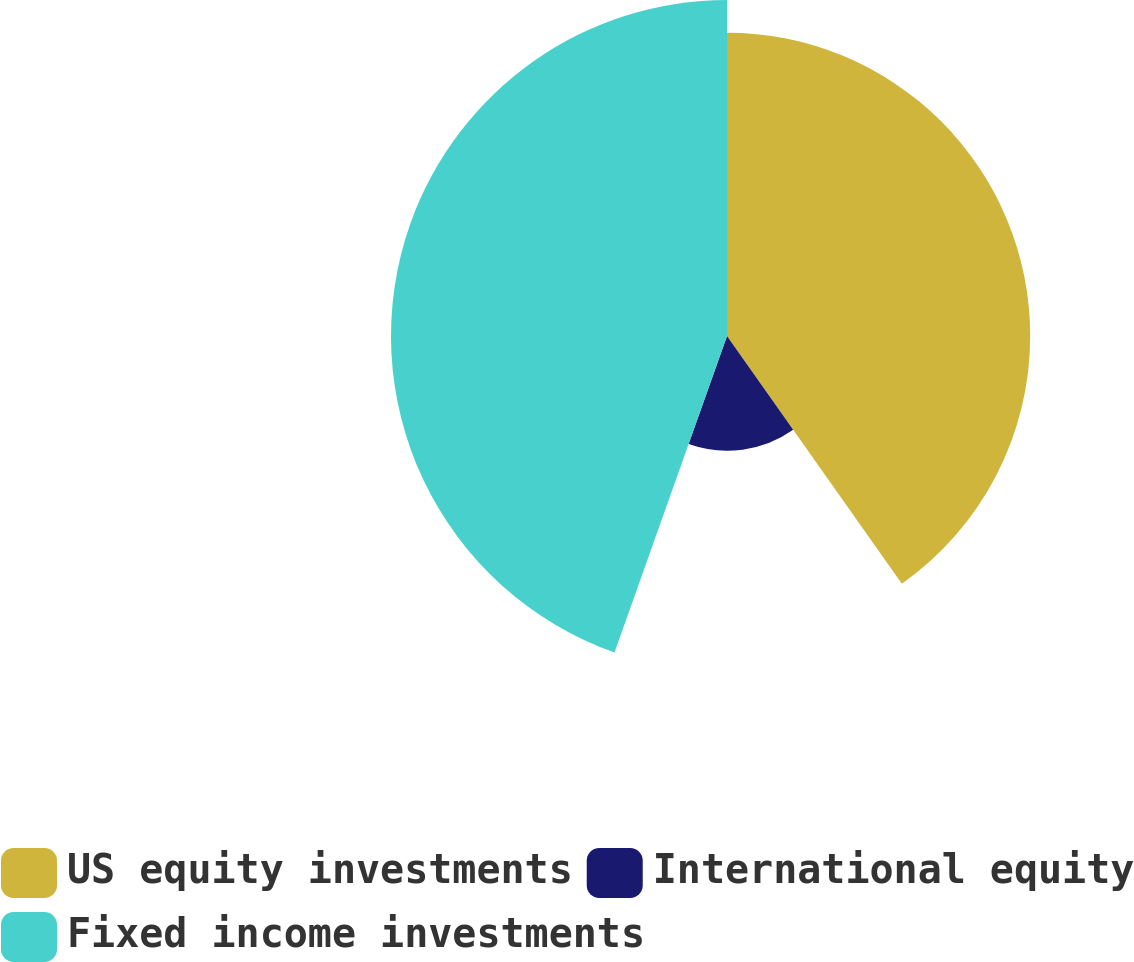Convert chart. <chart><loc_0><loc_0><loc_500><loc_500><pie_chart><fcel>US equity investments<fcel>International equity<fcel>Fixed income investments<nl><fcel>40.22%<fcel>15.22%<fcel>44.57%<nl></chart> 